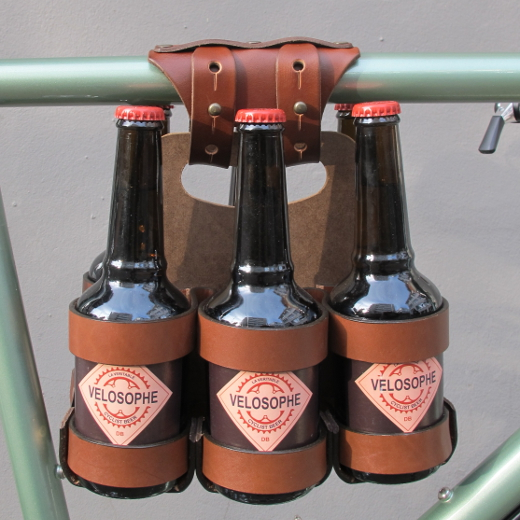What distinctive architectural elements can be observed among the skyscrapers in the cityscape, and how do they contribute to the overall aesthetic appeal of the scene? The skyscrapers in the cityscape present a fascinating mix of architectural elements. You'll notice sleek glass facades that reflect light beautifully, cutting-edge geometric designs that add a modern flair, and stunning illuminated patterns that bring the buildings to life, especially during nighttime. These features culminate in a visually dynamic and captivating urban landscape, creating an aesthetic that is both sophisticated and lively, making the cityscape a true visual spectacle. 